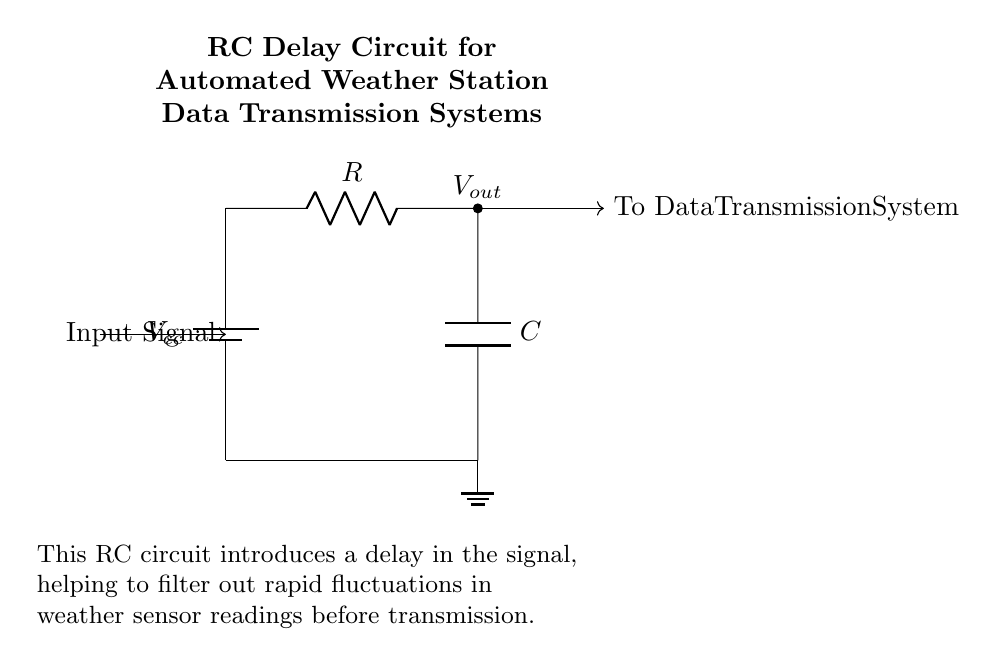What are the main components in this circuit? The main components are a resistor (R) and a capacitor (C). These components are labeled within the circuit diagram, indicating their roles in creating the RC delay.
Answer: Resistor and Capacitor What is the purpose of this circuit? The purpose of the circuit is to introduce a delay in the signal, which helps filter out rapid fluctuations in weather sensor readings before transmission. This is explained in the circuit notes, indicating that it is designed for weather station data transmission.
Answer: Signal delay and filtering What kind of circuit is this? This is an RC delay circuit, which combines a resistor and a capacitor to achieve a time delay in signal processing. The circuit type is indicated by the components used and their arrangement.
Answer: RC delay circuit What does the output voltage represent? The output voltage represents the voltage level after passing through the resistor and capacitor, which will have a delayed response to changes in the input signal. This is a characteristic of RC circuits.
Answer: Delayed voltage How does the value of the resistor affect the circuit? The value of the resistor affects the time constant of the RC circuit, which determines the rate at which the capacitor charges and discharges. A larger resistor will result in a longer delay, while a smaller resistor will shorten it.
Answer: Time constant What happens to the output signal with a larger capacitor value? A larger capacitor value increases the time constant, which results in a longer delay for the output signal. This happens because the capacitor takes more time to charge and discharge with a higher capacitance.
Answer: Longer delay 